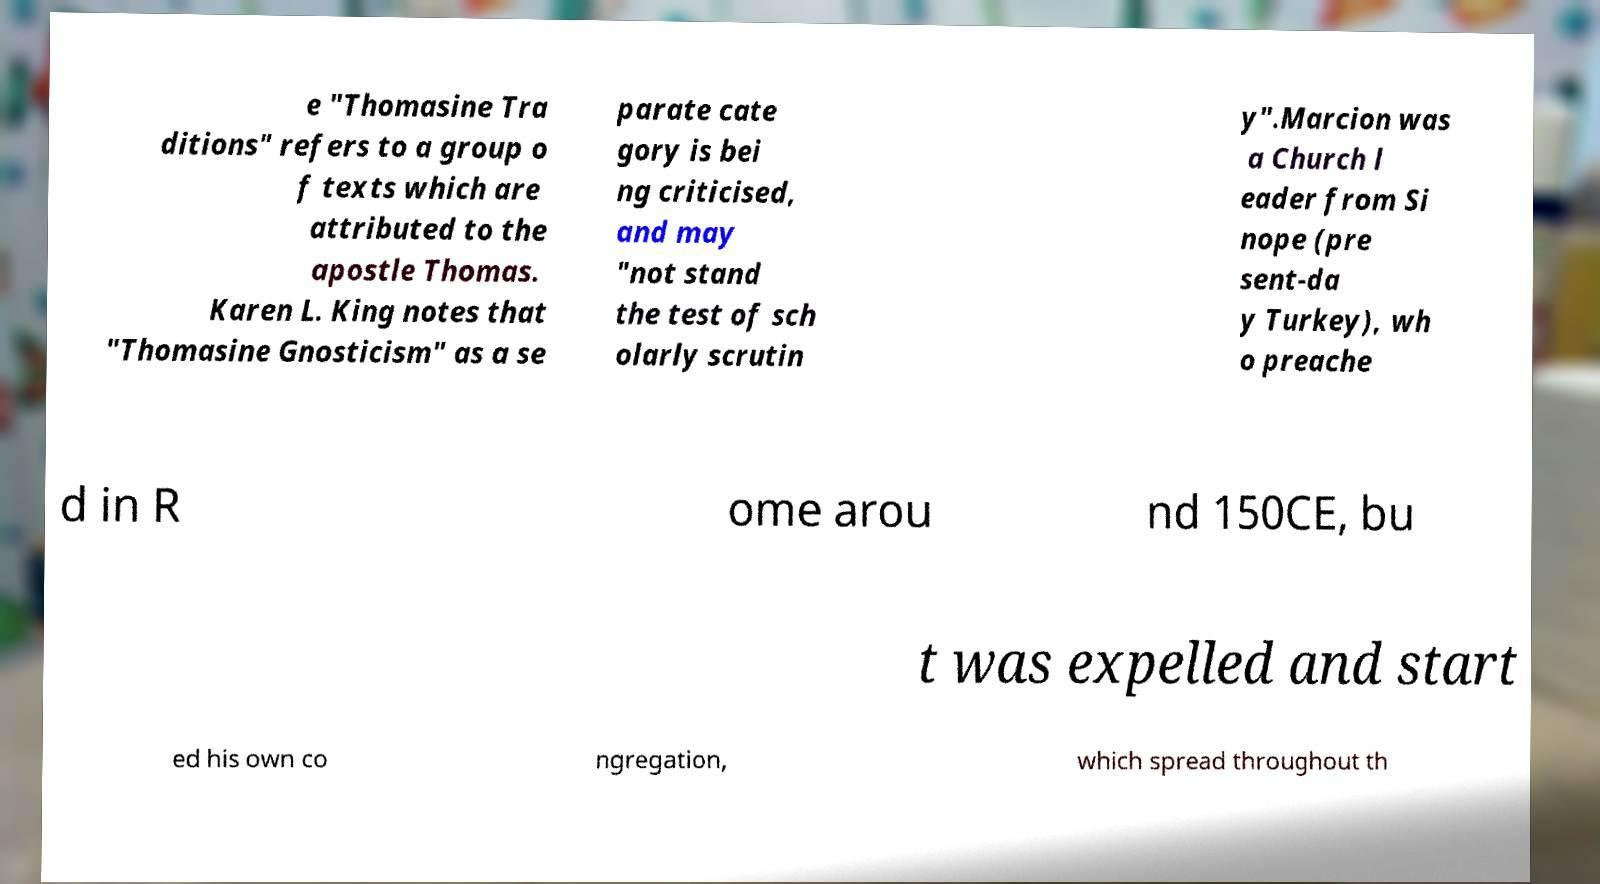Please read and relay the text visible in this image. What does it say? e "Thomasine Tra ditions" refers to a group o f texts which are attributed to the apostle Thomas. Karen L. King notes that "Thomasine Gnosticism" as a se parate cate gory is bei ng criticised, and may "not stand the test of sch olarly scrutin y".Marcion was a Church l eader from Si nope (pre sent-da y Turkey), wh o preache d in R ome arou nd 150CE, bu t was expelled and start ed his own co ngregation, which spread throughout th 